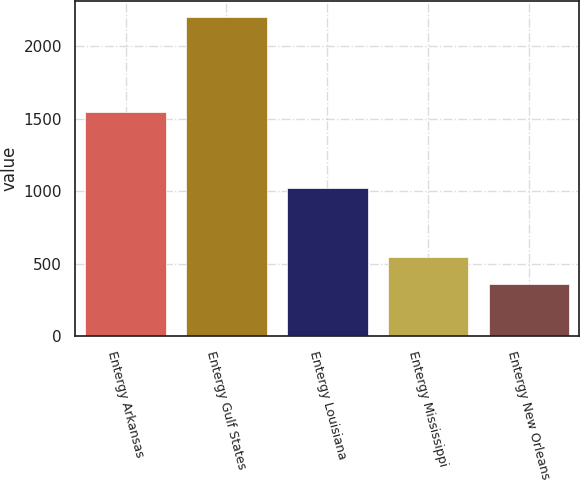Convert chart to OTSL. <chart><loc_0><loc_0><loc_500><loc_500><bar_chart><fcel>Entergy Arkansas<fcel>Entergy Gulf States<fcel>Entergy Louisiana<fcel>Entergy Mississippi<fcel>Entergy New Orleans<nl><fcel>1548<fcel>2205<fcel>1021<fcel>546.3<fcel>362<nl></chart> 